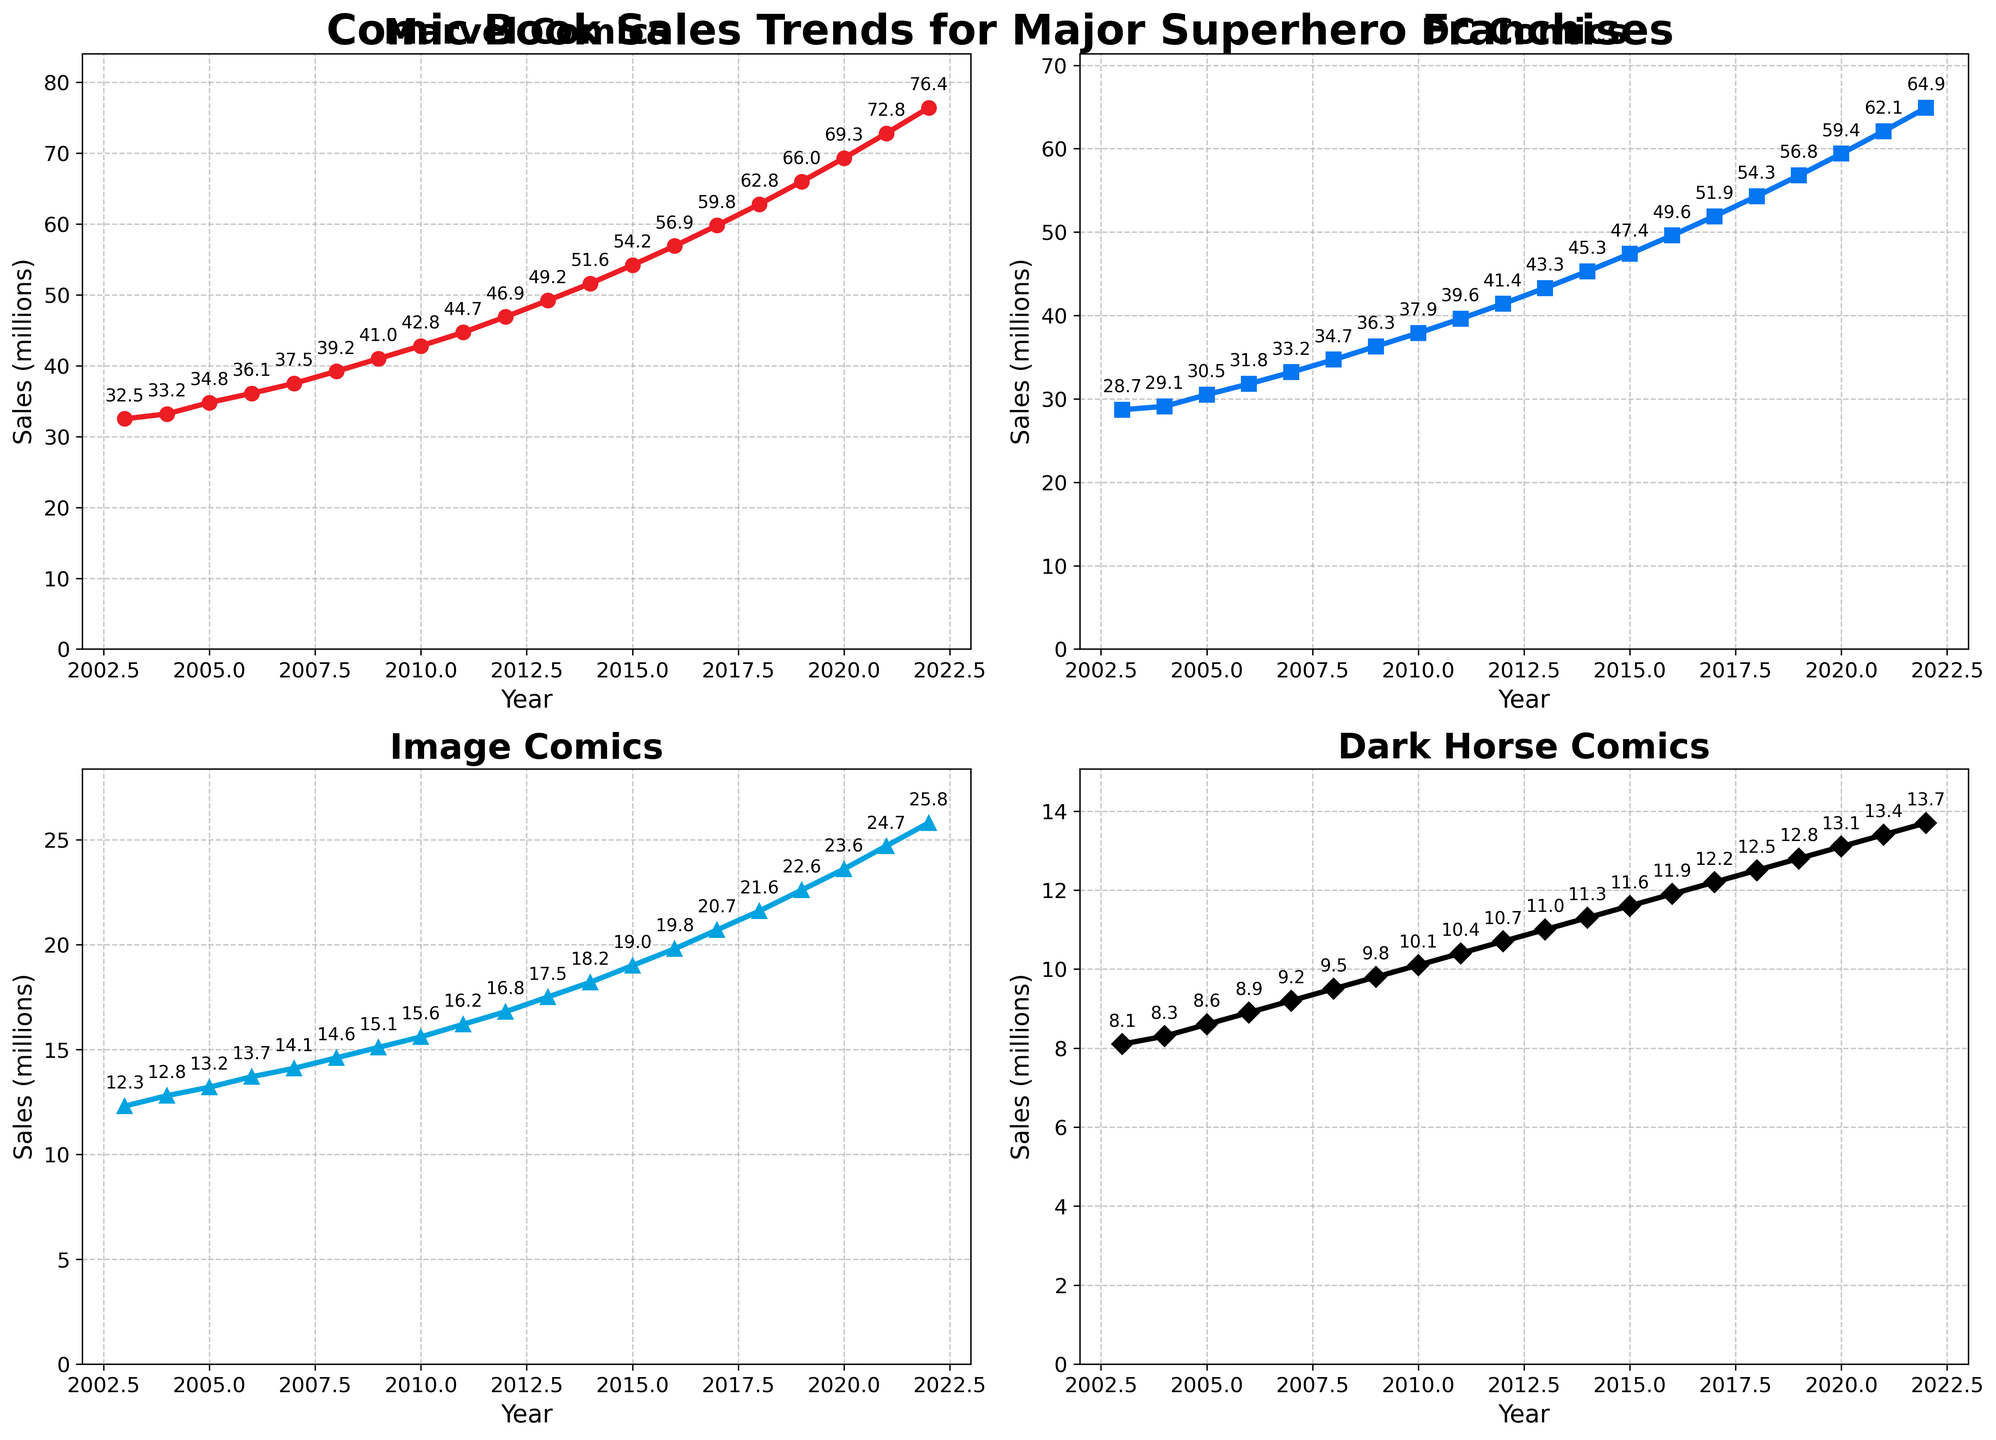Who experienced the largest sales increase from 2003 to 2022? Marvel went from 32.5 million in 2003 to 76.4 million in 2022. DC went from 28.7 million to 64.9 million. Image went from 12.3 million to 25.8 million, and Dark Horse went from 8.1 million to 13.7 million. The increase for each is Marvel: 43.9 million, DC: 36.2 million, Image: 13.5 million, Dark Horse: 5.6 million. Marvel experienced the largest increase.
Answer: Marvel Which company had the lowest sales in 2013? In 2013, Marvel had 49.2 million, DC had 43.3 million, Image had 17.5 million, and Dark Horse had 11 million. Dark Horse had the lowest sales in 2013.
Answer: Dark Horse By how much did Marvel's sales exceed Image's sales in 2020? Marvel's sales in 2020 were 69.3 million, and Image's sales were 23.6 million. The difference is 69.3 - 23.6 = 45.7 million.
Answer: 45.7 million What trend can be observed in DC's sales from 2003 to 2022? DC's sales increased from 28.7 million in 2003 to 64.9 million in 2022, showing a consistent upward trend over the 20 years.
Answer: Increasing trend Compare the sales trends of Image and Dark Horse from 2010 to 2020. Between 2010 and 2020, Image's sales increased from 15.6 million to 23.6 million, and Dark Horse's sales increased from 10.1 million to 13.1 million. Both companies showed upward trends, but Image's sales increased more significantly.
Answer: Both increased, Image more Which company had the highest sales in 2009? In 2009, Marvel had 41.0 million, DC had 36.3 million, Image had 15.1 million, and Dark Horse had 9.8 million. Marvel had the highest sales in 2009.
Answer: Marvel How did the sales gap between Marvel and DC change from 2003 to 2022? In 2003, Marvel's sales exceeded DC's by 32.5 - 28.7 = 3.8 million. In 2022, the gap increased to 76.4 - 64.9 = 11.5 million. The sales gap widened over the years.
Answer: Widened What's the average sales increase per year for Dark Horse from 2003 to 2022? Over 20 years, Dark Horse's sales increased from 8.1 million to 13.7 million, an increase of 13.7 - 8.1 = 5.6 million. The average annual increase is 5.6/20 = 0.28 million/year.
Answer: 0.28 million/year Which year did Marvel reach 50 million in sales? According to the plot, Marvel's sales reached 51.6 million in 2014.
Answer: 2014 What is the difference in sales between the lowest and highest sales companies in 2015? In 2015, Marvel had 54.2 million, DC had 47.4 million, Image had 19.0 million, and Dark Horse had 11.6 million. The difference between the highest (Marvel) and lowest (Dark Horse) is 54.2 - 11.6 = 42.6 million.
Answer: 42.6 million 